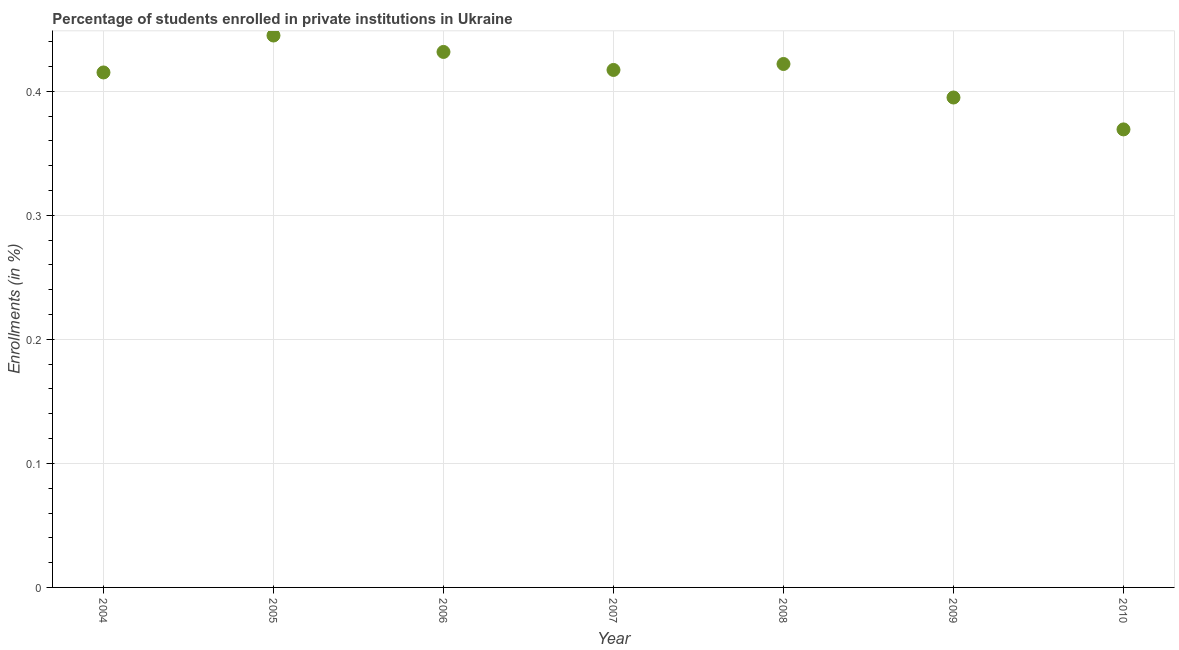What is the enrollments in private institutions in 2004?
Your answer should be compact. 0.42. Across all years, what is the maximum enrollments in private institutions?
Offer a terse response. 0.44. Across all years, what is the minimum enrollments in private institutions?
Ensure brevity in your answer.  0.37. In which year was the enrollments in private institutions maximum?
Make the answer very short. 2005. In which year was the enrollments in private institutions minimum?
Ensure brevity in your answer.  2010. What is the sum of the enrollments in private institutions?
Provide a succinct answer. 2.9. What is the difference between the enrollments in private institutions in 2007 and 2010?
Your answer should be compact. 0.05. What is the average enrollments in private institutions per year?
Your answer should be compact. 0.41. What is the median enrollments in private institutions?
Your answer should be compact. 0.42. In how many years, is the enrollments in private institutions greater than 0.06 %?
Provide a short and direct response. 7. What is the ratio of the enrollments in private institutions in 2006 to that in 2008?
Provide a succinct answer. 1.02. What is the difference between the highest and the second highest enrollments in private institutions?
Your answer should be very brief. 0.01. What is the difference between the highest and the lowest enrollments in private institutions?
Keep it short and to the point. 0.08. In how many years, is the enrollments in private institutions greater than the average enrollments in private institutions taken over all years?
Offer a terse response. 5. How many dotlines are there?
Provide a succinct answer. 1. What is the difference between two consecutive major ticks on the Y-axis?
Provide a short and direct response. 0.1. Does the graph contain any zero values?
Provide a succinct answer. No. Does the graph contain grids?
Offer a terse response. Yes. What is the title of the graph?
Offer a terse response. Percentage of students enrolled in private institutions in Ukraine. What is the label or title of the X-axis?
Your answer should be compact. Year. What is the label or title of the Y-axis?
Your answer should be compact. Enrollments (in %). What is the Enrollments (in %) in 2004?
Give a very brief answer. 0.42. What is the Enrollments (in %) in 2005?
Offer a terse response. 0.44. What is the Enrollments (in %) in 2006?
Keep it short and to the point. 0.43. What is the Enrollments (in %) in 2007?
Provide a succinct answer. 0.42. What is the Enrollments (in %) in 2008?
Keep it short and to the point. 0.42. What is the Enrollments (in %) in 2009?
Your answer should be compact. 0.39. What is the Enrollments (in %) in 2010?
Your response must be concise. 0.37. What is the difference between the Enrollments (in %) in 2004 and 2005?
Ensure brevity in your answer.  -0.03. What is the difference between the Enrollments (in %) in 2004 and 2006?
Ensure brevity in your answer.  -0.02. What is the difference between the Enrollments (in %) in 2004 and 2007?
Give a very brief answer. -0. What is the difference between the Enrollments (in %) in 2004 and 2008?
Provide a short and direct response. -0.01. What is the difference between the Enrollments (in %) in 2004 and 2009?
Give a very brief answer. 0.02. What is the difference between the Enrollments (in %) in 2004 and 2010?
Offer a terse response. 0.05. What is the difference between the Enrollments (in %) in 2005 and 2006?
Your answer should be very brief. 0.01. What is the difference between the Enrollments (in %) in 2005 and 2007?
Make the answer very short. 0.03. What is the difference between the Enrollments (in %) in 2005 and 2008?
Your response must be concise. 0.02. What is the difference between the Enrollments (in %) in 2005 and 2009?
Your answer should be very brief. 0.05. What is the difference between the Enrollments (in %) in 2005 and 2010?
Offer a terse response. 0.08. What is the difference between the Enrollments (in %) in 2006 and 2007?
Provide a succinct answer. 0.01. What is the difference between the Enrollments (in %) in 2006 and 2008?
Your response must be concise. 0.01. What is the difference between the Enrollments (in %) in 2006 and 2009?
Provide a short and direct response. 0.04. What is the difference between the Enrollments (in %) in 2006 and 2010?
Keep it short and to the point. 0.06. What is the difference between the Enrollments (in %) in 2007 and 2008?
Your response must be concise. -0. What is the difference between the Enrollments (in %) in 2007 and 2009?
Provide a short and direct response. 0.02. What is the difference between the Enrollments (in %) in 2007 and 2010?
Make the answer very short. 0.05. What is the difference between the Enrollments (in %) in 2008 and 2009?
Offer a terse response. 0.03. What is the difference between the Enrollments (in %) in 2008 and 2010?
Make the answer very short. 0.05. What is the difference between the Enrollments (in %) in 2009 and 2010?
Provide a short and direct response. 0.03. What is the ratio of the Enrollments (in %) in 2004 to that in 2005?
Give a very brief answer. 0.93. What is the ratio of the Enrollments (in %) in 2004 to that in 2006?
Make the answer very short. 0.96. What is the ratio of the Enrollments (in %) in 2004 to that in 2007?
Your answer should be compact. 0.99. What is the ratio of the Enrollments (in %) in 2004 to that in 2009?
Your answer should be very brief. 1.05. What is the ratio of the Enrollments (in %) in 2004 to that in 2010?
Make the answer very short. 1.12. What is the ratio of the Enrollments (in %) in 2005 to that in 2006?
Your response must be concise. 1.03. What is the ratio of the Enrollments (in %) in 2005 to that in 2007?
Provide a short and direct response. 1.07. What is the ratio of the Enrollments (in %) in 2005 to that in 2008?
Keep it short and to the point. 1.05. What is the ratio of the Enrollments (in %) in 2005 to that in 2009?
Your answer should be compact. 1.13. What is the ratio of the Enrollments (in %) in 2005 to that in 2010?
Keep it short and to the point. 1.21. What is the ratio of the Enrollments (in %) in 2006 to that in 2007?
Provide a short and direct response. 1.03. What is the ratio of the Enrollments (in %) in 2006 to that in 2008?
Your answer should be compact. 1.02. What is the ratio of the Enrollments (in %) in 2006 to that in 2009?
Offer a terse response. 1.09. What is the ratio of the Enrollments (in %) in 2006 to that in 2010?
Provide a short and direct response. 1.17. What is the ratio of the Enrollments (in %) in 2007 to that in 2008?
Make the answer very short. 0.99. What is the ratio of the Enrollments (in %) in 2007 to that in 2009?
Offer a terse response. 1.06. What is the ratio of the Enrollments (in %) in 2007 to that in 2010?
Offer a very short reply. 1.13. What is the ratio of the Enrollments (in %) in 2008 to that in 2009?
Keep it short and to the point. 1.07. What is the ratio of the Enrollments (in %) in 2008 to that in 2010?
Your answer should be compact. 1.14. What is the ratio of the Enrollments (in %) in 2009 to that in 2010?
Give a very brief answer. 1.07. 